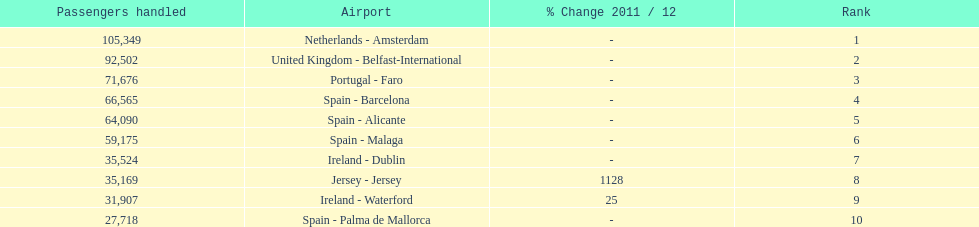Which airport has the least amount of passengers going through london southend airport? Spain - Palma de Mallorca. 